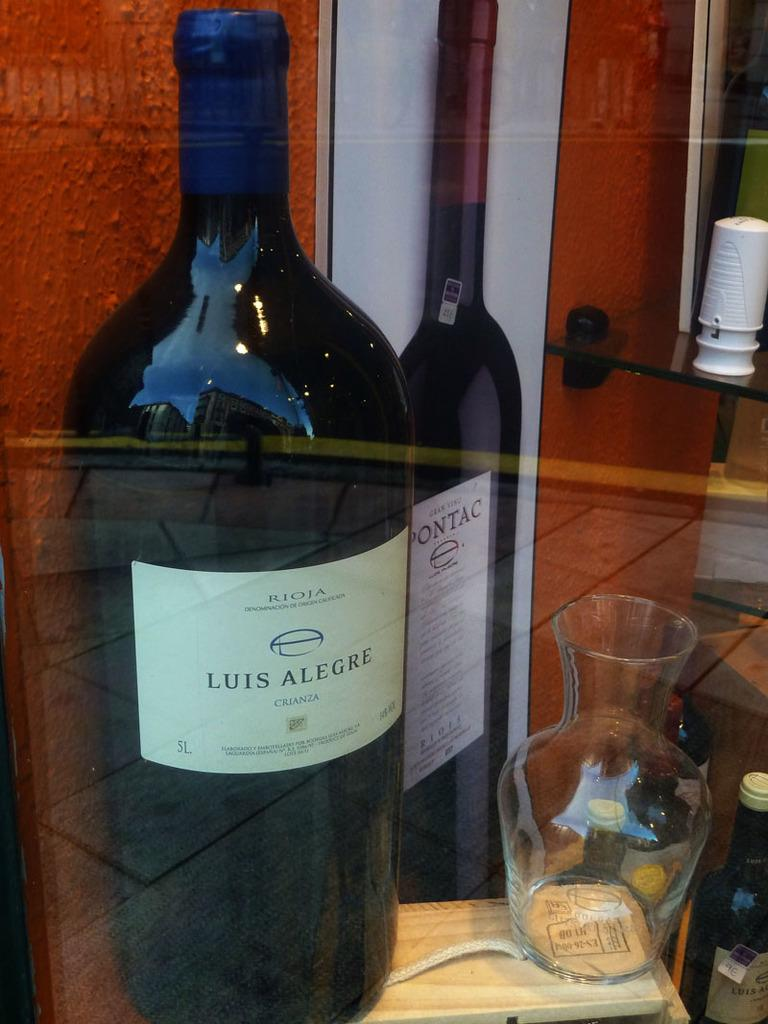<image>
Present a compact description of the photo's key features. A bottle of Luis Alegre wine is on display. 